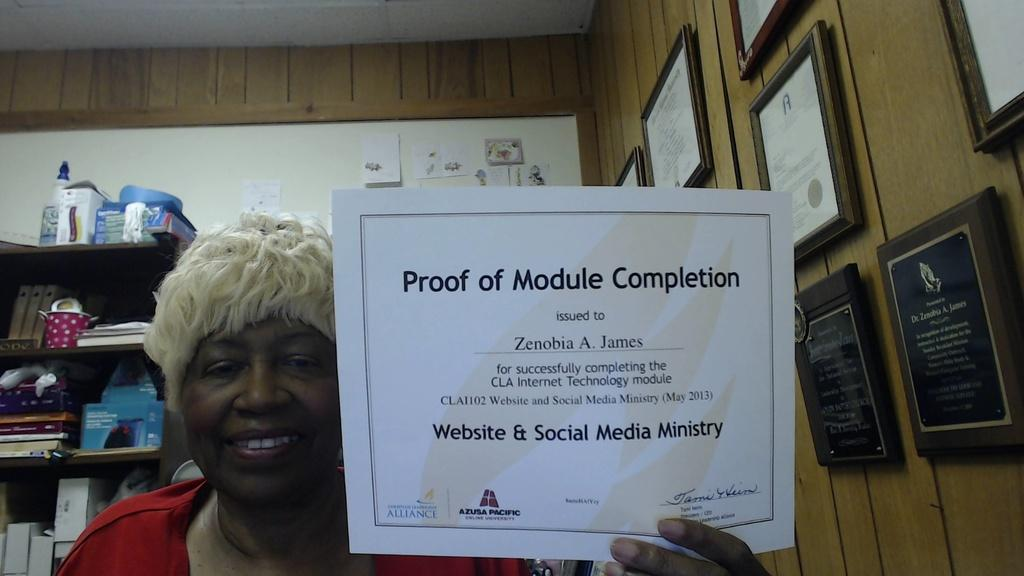<image>
Present a compact description of the photo's key features. A woman holding up a certificate that says Proof of Module Completion. 